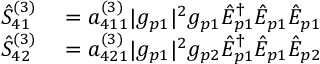<formula> <loc_0><loc_0><loc_500><loc_500>\begin{array} { r l } { \hat { S } _ { 4 1 } ^ { ( 3 ) } } & = a _ { 4 1 1 } ^ { ( 3 ) } | g _ { p 1 } | ^ { 2 } g _ { p 1 } \hat { E } _ { p 1 } ^ { \dagger } \hat { E } _ { p 1 } \hat { E } _ { p 1 } } \\ { \hat { S } _ { 4 2 } ^ { ( 3 ) } } & = a _ { 4 2 1 } ^ { ( 3 ) } | g _ { p 1 } | ^ { 2 } g _ { p 2 } \hat { E } _ { p 1 } ^ { \dagger } \hat { E } _ { p 1 } \hat { E } _ { p 2 } } \end{array}</formula> 